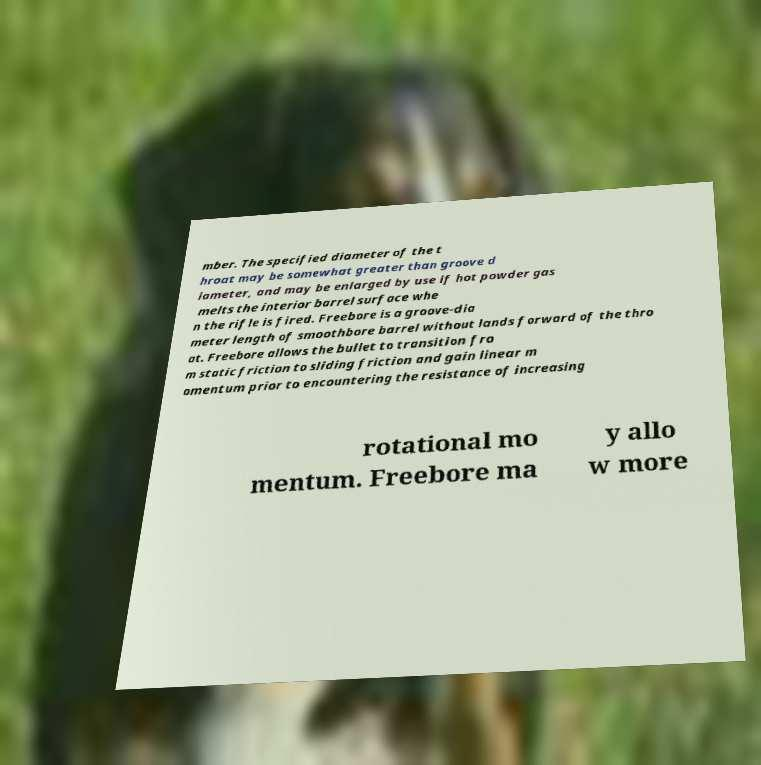Could you assist in decoding the text presented in this image and type it out clearly? mber. The specified diameter of the t hroat may be somewhat greater than groove d iameter, and may be enlarged by use if hot powder gas melts the interior barrel surface whe n the rifle is fired. Freebore is a groove-dia meter length of smoothbore barrel without lands forward of the thro at. Freebore allows the bullet to transition fro m static friction to sliding friction and gain linear m omentum prior to encountering the resistance of increasing rotational mo mentum. Freebore ma y allo w more 